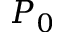Convert formula to latex. <formula><loc_0><loc_0><loc_500><loc_500>P _ { 0 }</formula> 